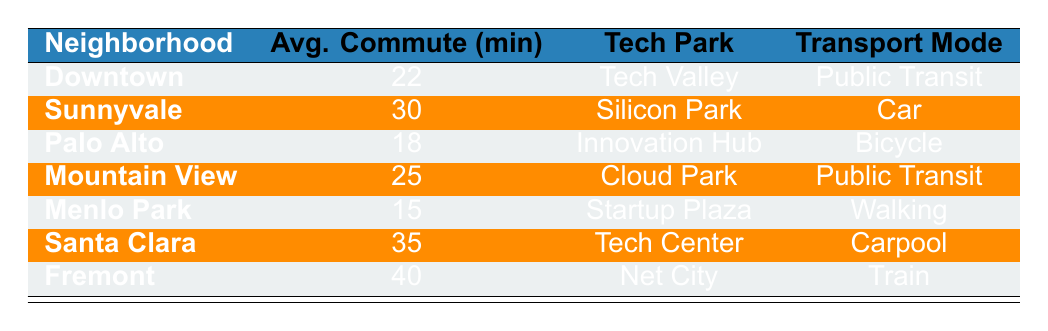What is the average commute time for the neighborhood of Menlo Park? The table shows that the average commute time for Menlo Park is listed directly under the corresponding row. The value is 15 minutes.
Answer: 15 Which neighborhood has the shortest commute time to its tech park? By comparing the average commute times listed in the table, Menlo Park has the shortest average time of 15 minutes.
Answer: Menlo Park Is it true that the average commute time to Tech Valley from Downtown is 22 minutes? The table specifies that the average commute time from Downtown to Tech Valley is indeed 22 minutes, so this statement is true.
Answer: Yes What is the difference in average commute times between Sunnyvale and Palo Alto? The table shows that Sunnyvale has an average commute time of 30 minutes while Palo Alto has 18 minutes. The difference is calculated as 30 - 18 = 12 minutes.
Answer: 12 If you combine the average commute times of all neighborhoods listed, what is the total? The average commute times are 22, 30, 18, 25, 15, 35, and 40 minutes. Summing these gives: 22 + 30 + 18 + 25 + 15 + 35 + 40 = 215 minutes.
Answer: 215 Which transport mode is used to commute to Cloud Park? The table indicates that the transport mode for commutes to Cloud Park is Public Transit.
Answer: Public Transit Are there any neighborhoods from which commuting to the tech park takes longer than 30 minutes? From the table, Santa Clara (35 minutes) and Fremont (40 minutes) both have commute times longer than 30 minutes. Therefore, the answer is yes.
Answer: Yes What is the average commute time for neighborhoods using public transit? The neighborhoods using public transit are Downtown (22 min) and Mountain View (25 min). The total for these neighborhoods is 22 + 25 = 47 minutes, and there are 2 data points, so the average is 47/2 = 23.5 minutes.
Answer: 23.5 Which tech park has the longest commute time associated with it? Reviewing the table, Fremont has the longest commute time of 40 minutes to Net City, which is more than the other tech parks listed.
Answer: Net City 